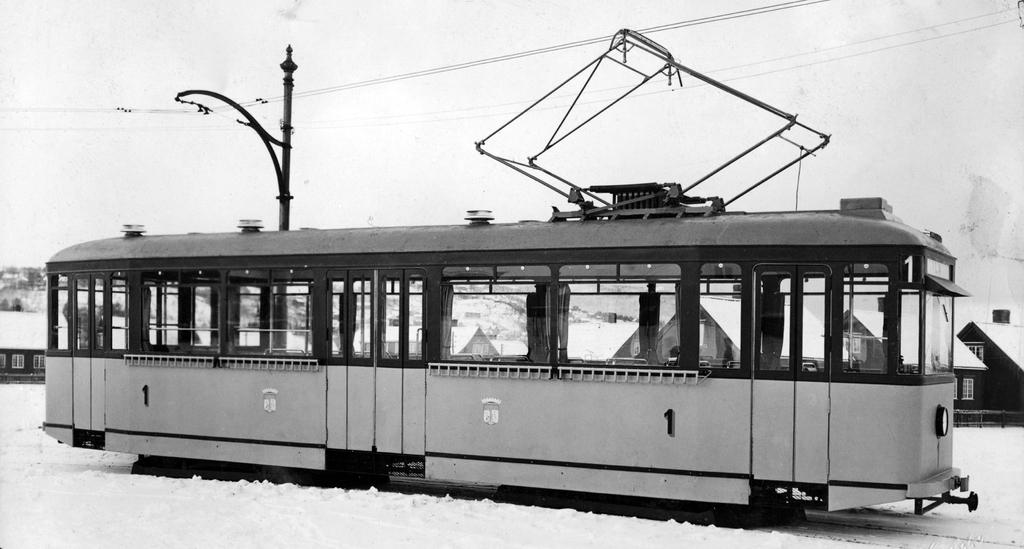What is the main subject in the image? There is a vehicle in the image. What else can be seen in the image besides the vehicle? There are houses and wires visible in the image. What is the weather like in the image? There is snow visible in the image, indicating a cold or wintery environment. What is visible in the background of the image? The sky is visible in the background of the image. Can you tell me how the farmer is using the yoke in the image? There is no farmer or yoke present in the image. What is the vehicle in the image drawing the attention of the people? The image does not depict any people or their attention, so it is not possible to answer this question. 